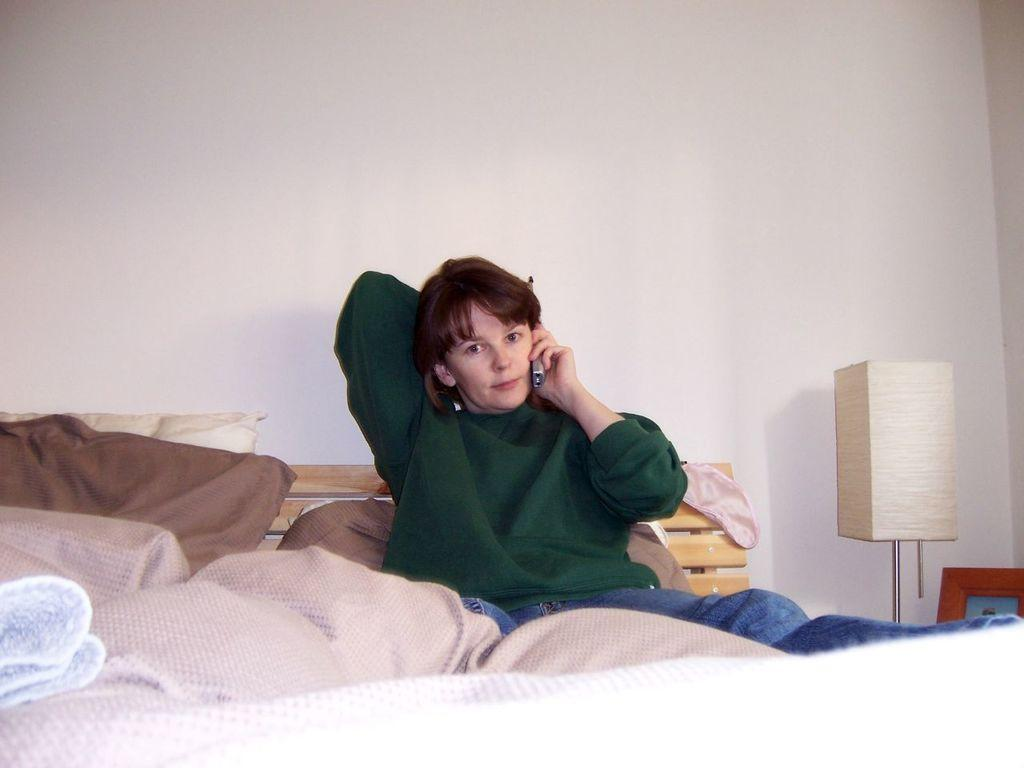Who is in the image? There is a boy in the image. What is the boy doing in the image? The boy is talking on a phone. Where is the boy located in the image? The boy is sitting on a bed. What else can be seen on the bed in the image? There is a blanket and pillows on the bed. What is the source of light in the image? There is a lamp in the image. How many spiders are crawling on the boy in the image? There are no spiders visible in the image; the boy is talking on a phone while sitting on a bed. What authority figure is present in the image? There is no authority figure present in the image; it only features a boy talking on a phone while sitting on a bed. 